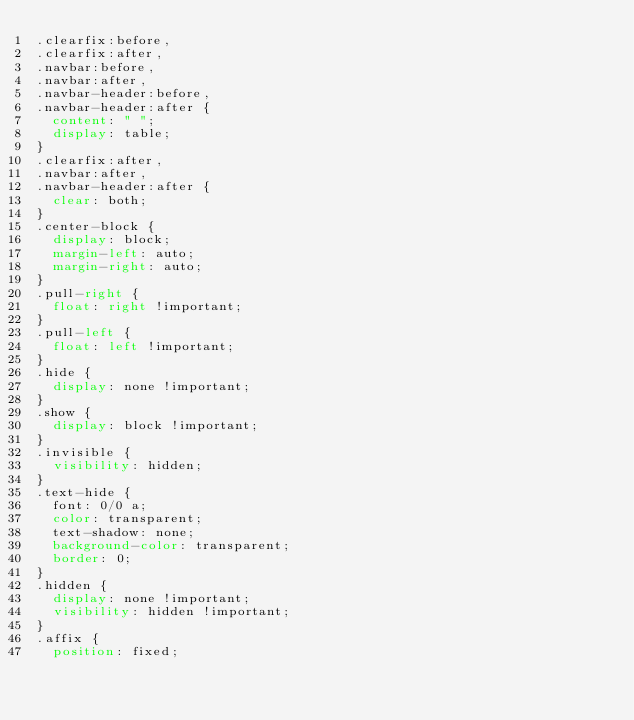<code> <loc_0><loc_0><loc_500><loc_500><_CSS_>.clearfix:before,
.clearfix:after,
.navbar:before,
.navbar:after,
.navbar-header:before,
.navbar-header:after {
  content: " ";
  display: table;
}
.clearfix:after,
.navbar:after,
.navbar-header:after {
  clear: both;
}
.center-block {
  display: block;
  margin-left: auto;
  margin-right: auto;
}
.pull-right {
  float: right !important;
}
.pull-left {
  float: left !important;
}
.hide {
  display: none !important;
}
.show {
  display: block !important;
}
.invisible {
  visibility: hidden;
}
.text-hide {
  font: 0/0 a;
  color: transparent;
  text-shadow: none;
  background-color: transparent;
  border: 0;
}
.hidden {
  display: none !important;
  visibility: hidden !important;
}
.affix {
  position: fixed;</code> 